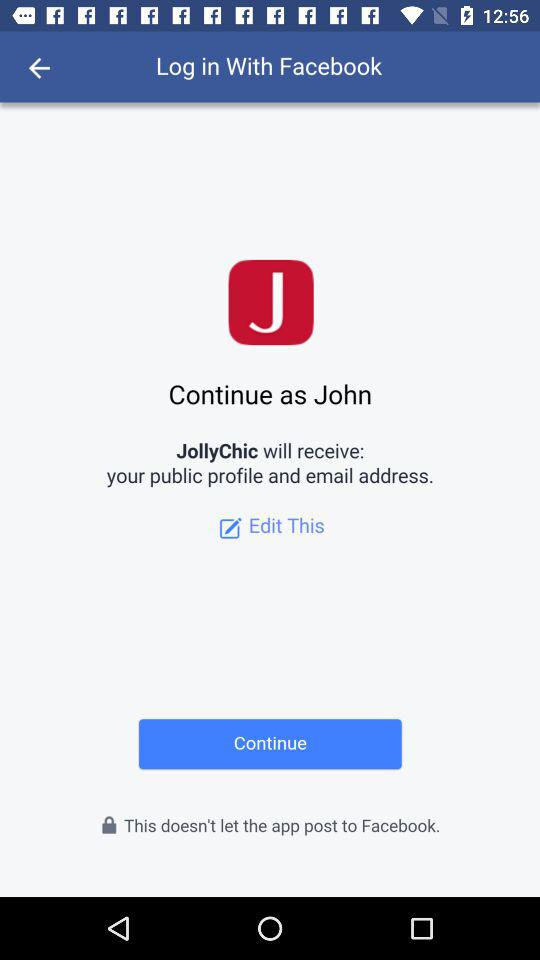What information will JollyChic receive? JollyChic will receive your public profile and email address. 